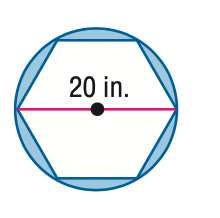Answer the mathemtical geometry problem and directly provide the correct option letter.
Question: Find the area of the shaded region. Assume that all polygons that appear to be regular are regular. Round to the nearest tenth.
Choices: A: 54.4 B: 97.6 C: 108.8 D: 184.2 A 